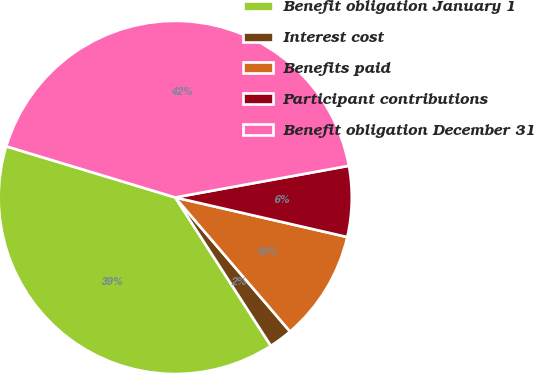Convert chart. <chart><loc_0><loc_0><loc_500><loc_500><pie_chart><fcel>Benefit obligation January 1<fcel>Interest cost<fcel>Benefits paid<fcel>Participant contributions<fcel>Benefit obligation December 31<nl><fcel>38.79%<fcel>2.16%<fcel>10.13%<fcel>6.47%<fcel>42.46%<nl></chart> 